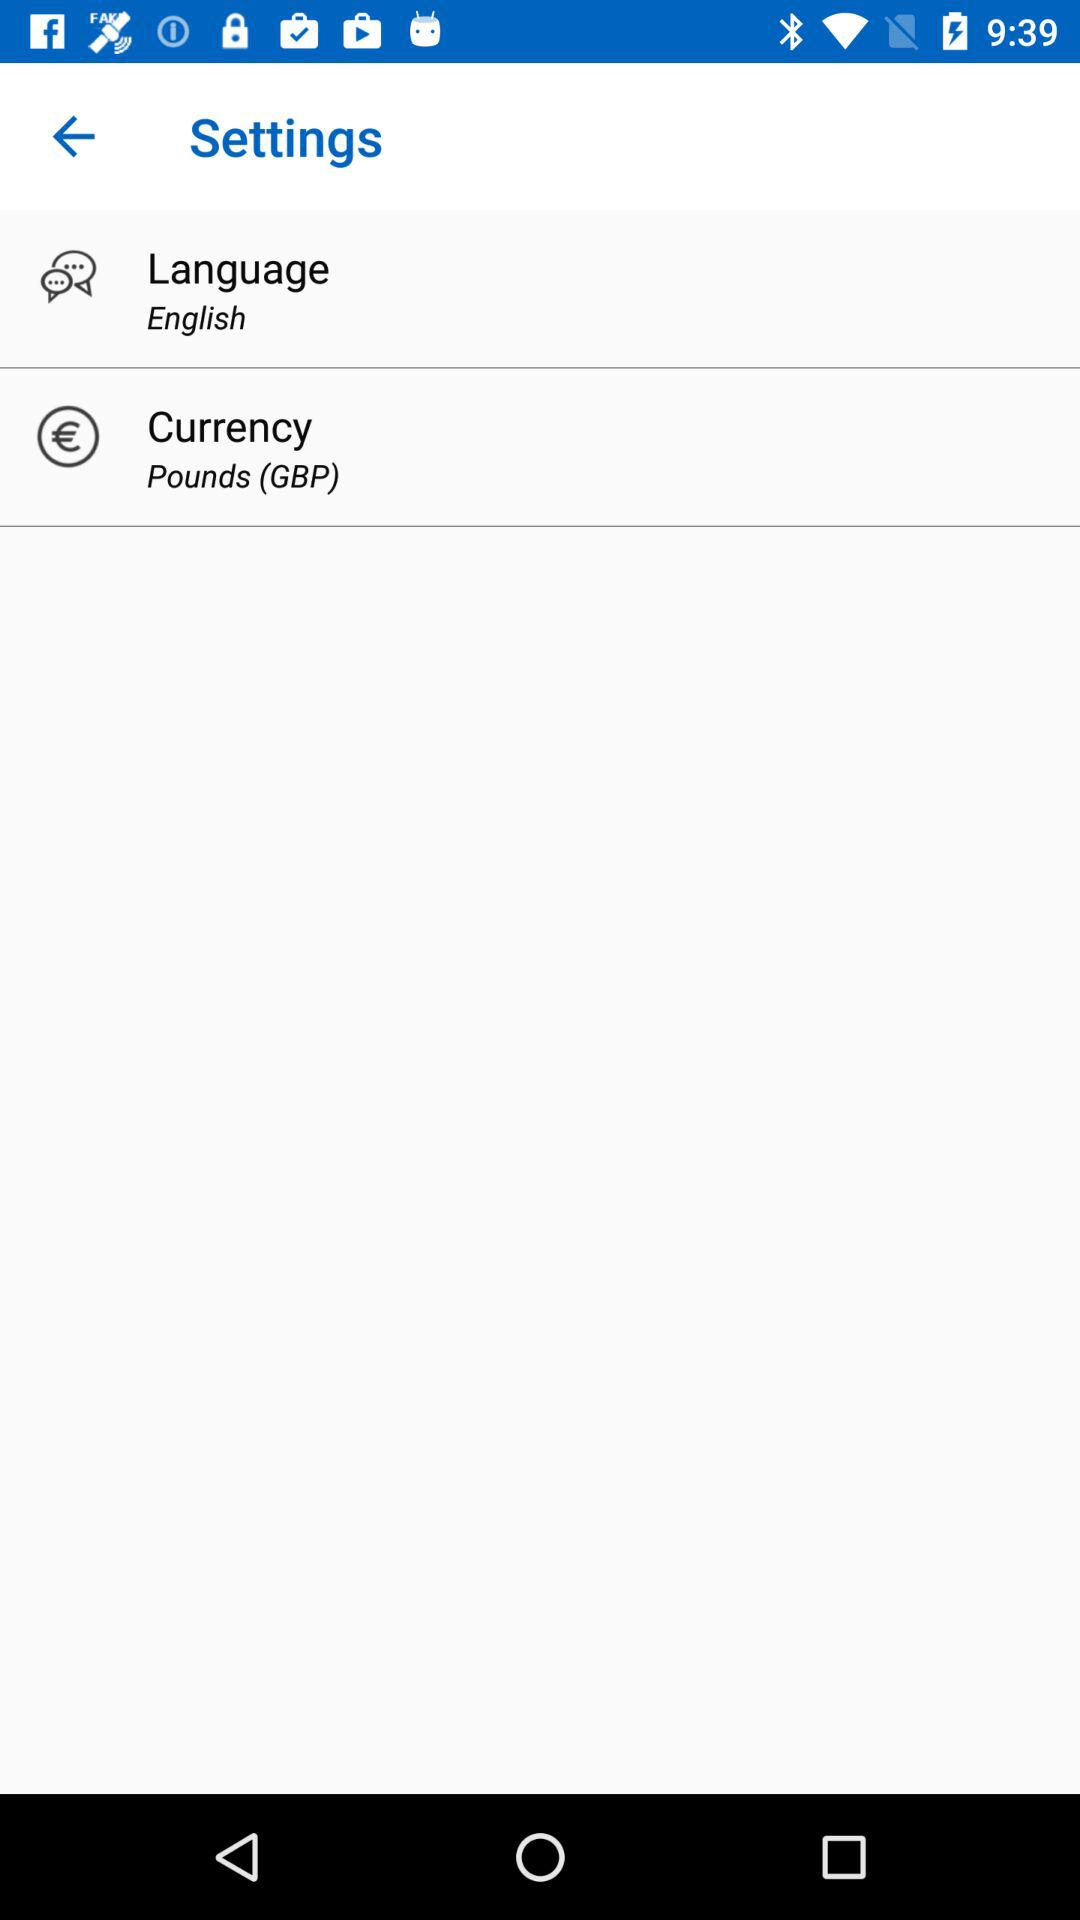Which language is selected? The selected language is English. 